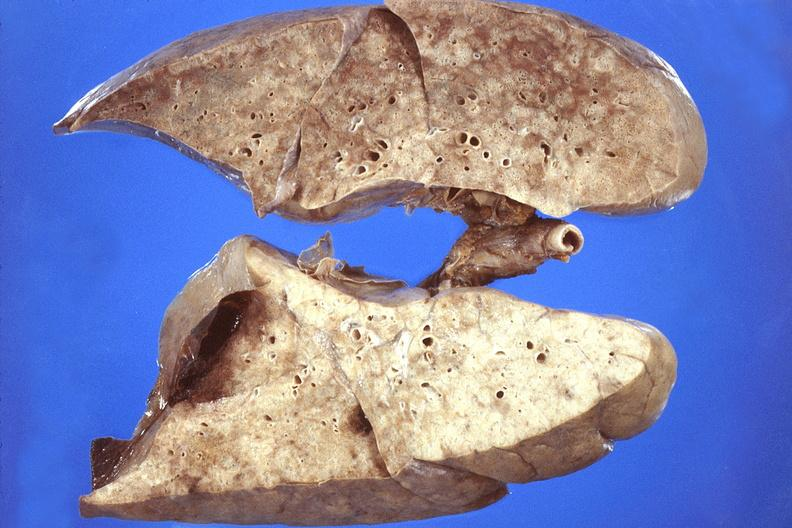where is this?
Answer the question using a single word or phrase. Lung 